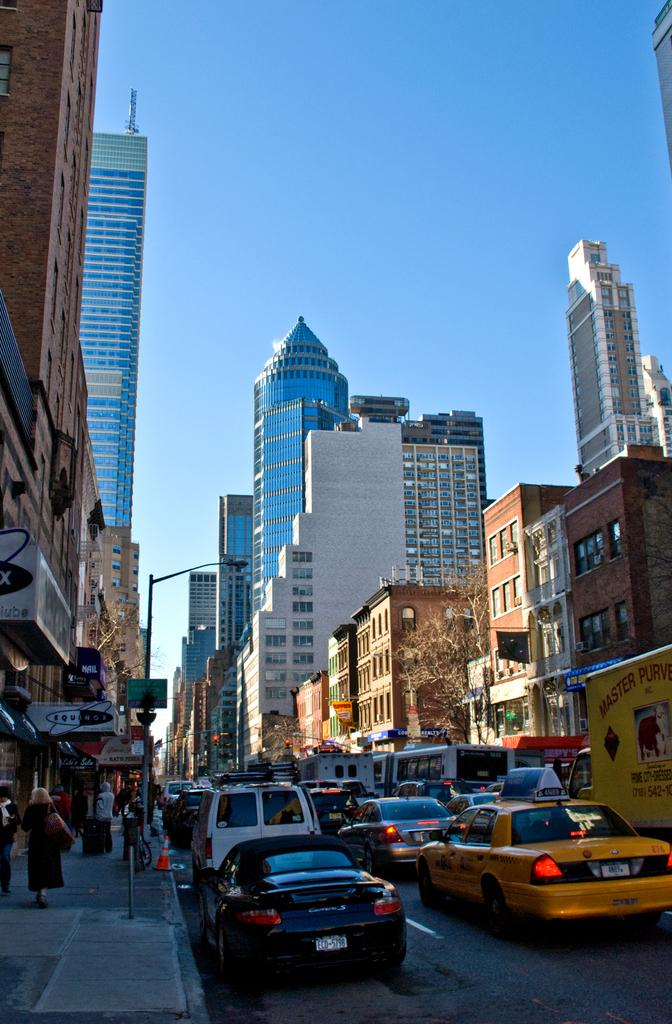<image>
Relay a brief, clear account of the picture shown. A street scene which contains a black car with the letters ECD on the licence plate. 